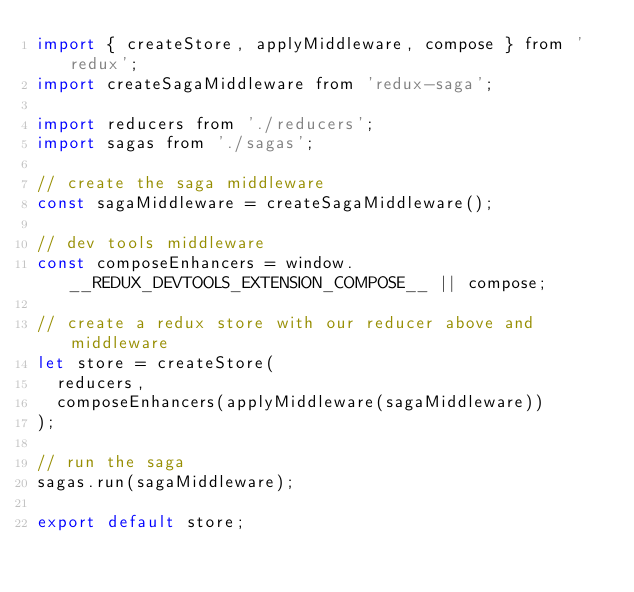<code> <loc_0><loc_0><loc_500><loc_500><_JavaScript_>import { createStore, applyMiddleware, compose } from 'redux';
import createSagaMiddleware from 'redux-saga';

import reducers from './reducers';
import sagas from './sagas';

// create the saga middleware
const sagaMiddleware = createSagaMiddleware();

// dev tools middleware
const composeEnhancers = window.__REDUX_DEVTOOLS_EXTENSION_COMPOSE__ || compose;

// create a redux store with our reducer above and middleware
let store = createStore(
  reducers,
  composeEnhancers(applyMiddleware(sagaMiddleware))
);

// run the saga
sagas.run(sagaMiddleware);

export default store;
</code> 